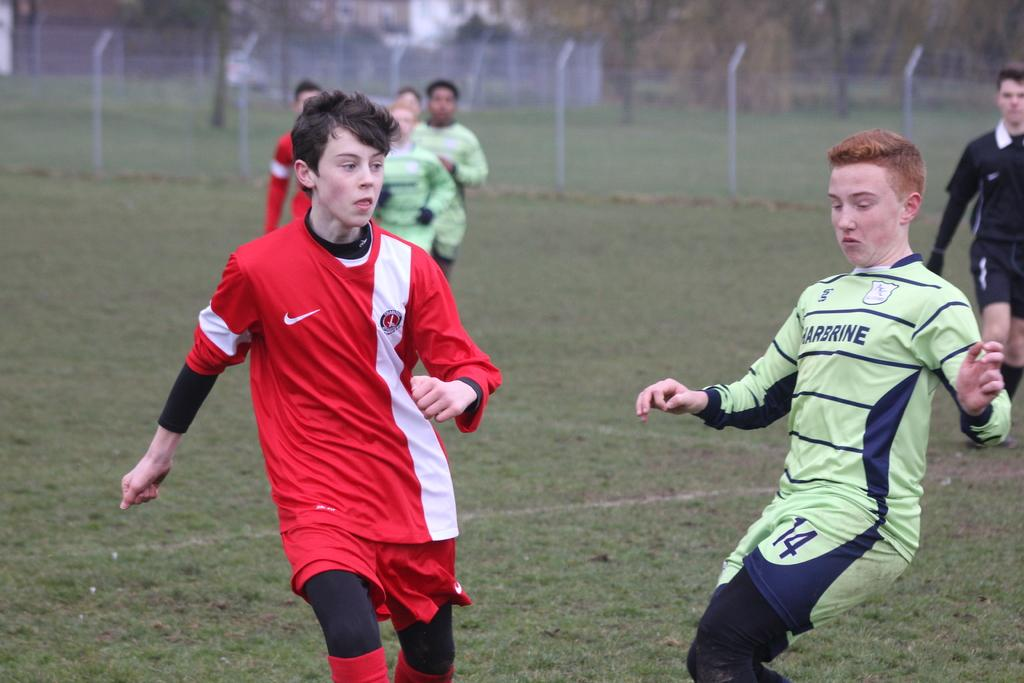<image>
Share a concise interpretation of the image provided. A soccer game with one team in red uniforms and the other in light green Harbrine uniforms. 